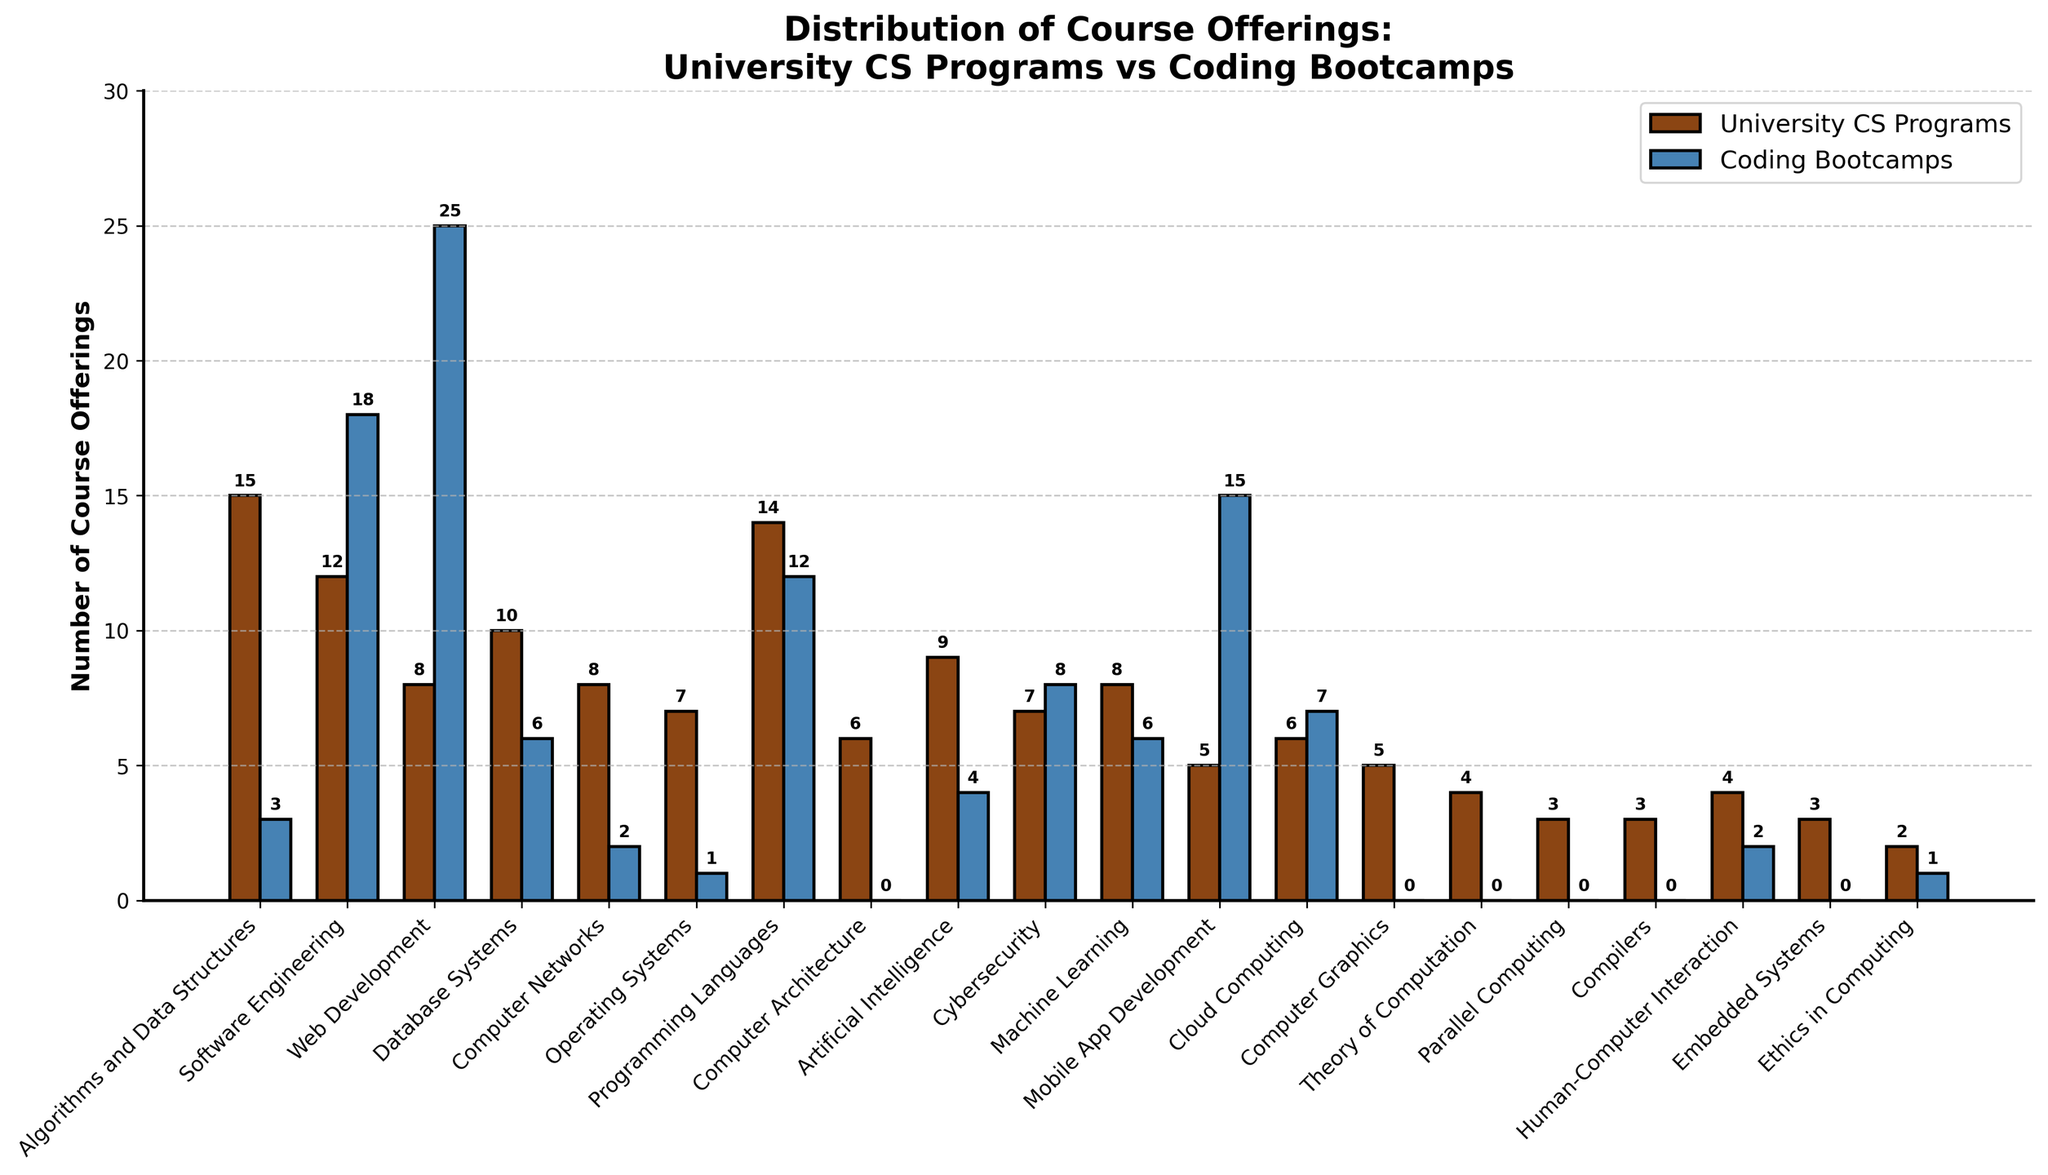Which course type has the highest number of offerings in coding bootcamps? The bar for Web Development in coding bootcamps is the tallest.
Answer: Web Development What is the difference in the number of offerings for Software Engineering between university CS programs and coding bootcamps? The height of the bar for Software Engineering in university CS programs is 12, and in coding bootcamps, it is 18. The difference is 18 - 12 = 6.
Answer: 6 Which course type shows the largest disparity in offerings between university CS programs and coding bootcamps? Web Development shows the largest disparity as it has 8 offerings in university CS programs and 25 in coding bootcamps. The difference is 25 - 8 = 17.
Answer: Web Development How many more courses related to Operating Systems are offered by university CS programs compared to coding bootcamps? The bar for Operating Systems shows 7 offerings in university CS programs and 1 in coding bootcamps. The difference is 7 - 1 = 6.
Answer: 6 What is the total number of Machine Learning courses offered by both university CS programs and coding bootcamps? The bar for Machine Learning shows 8 courses for university CS programs and 6 for coding bootcamps. The total sum is 8 + 6 = 14.
Answer: 14 How do the offerings of Cybersecurity courses compare between university CS programs and coding bootcamps? The bar for Cybersecurity shows 7 offerings in university CS programs and 8 in coding bootcamps. Coding bootcamps offer 1 more course.
Answer: Coding bootcamps offer 1 more Are there any course types exclusively offered by university CS programs and not by coding bootcamps? Courses like Computer Architecture, Computer Graphics, Theory of Computation, Parallel Computing, Compilers, Embedded Systems are exclusively offered by university CS programs, with no offerings in coding bootcamps.
Answer: Yes Does any course type have equal offerings in both university CS programs and coding bootcamps? The bar for Programming Languages shows 14 offerings in both university CS programs and coding bootcamps.
Answer: Yes, Programming Languages Which visual attribute helps identify the courses offered more by universities compared to coding bootcamps? Taller brown bars, representing university CS programs, indicate more course offerings compared to shorter blue bars for coding bootcamps.
Answer: Taller brown bars What is the mean number of course offerings by university CS programs? Sum the university CS programs' course offerings (15+12+8+10+8+7+14+6+9+7+8+5+6+5+4+3+3+4+3+2 = 141) and divide by the number of course types (20). The mean is 141/20 = 7.05.
Answer: 7.05 